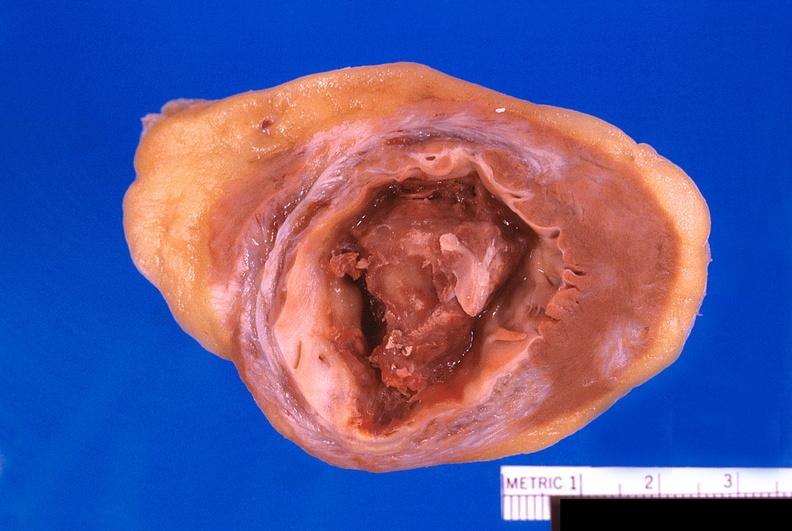what is present?
Answer the question using a single word or phrase. Cardiovascular 